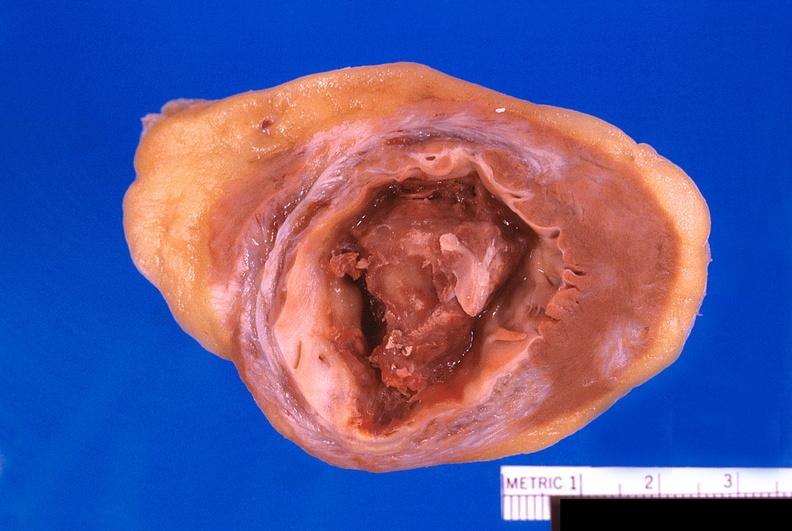what is present?
Answer the question using a single word or phrase. Cardiovascular 